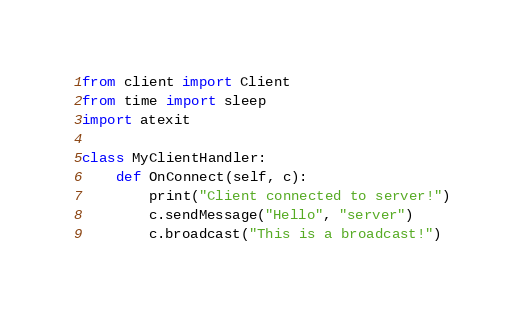<code> <loc_0><loc_0><loc_500><loc_500><_Python_>from client import Client
from time import sleep
import atexit

class MyClientHandler:
    def OnConnect(self, c):
        print("Client connected to server!")
        c.sendMessage("Hello", "server")
        c.broadcast("This is a broadcast!")</code> 